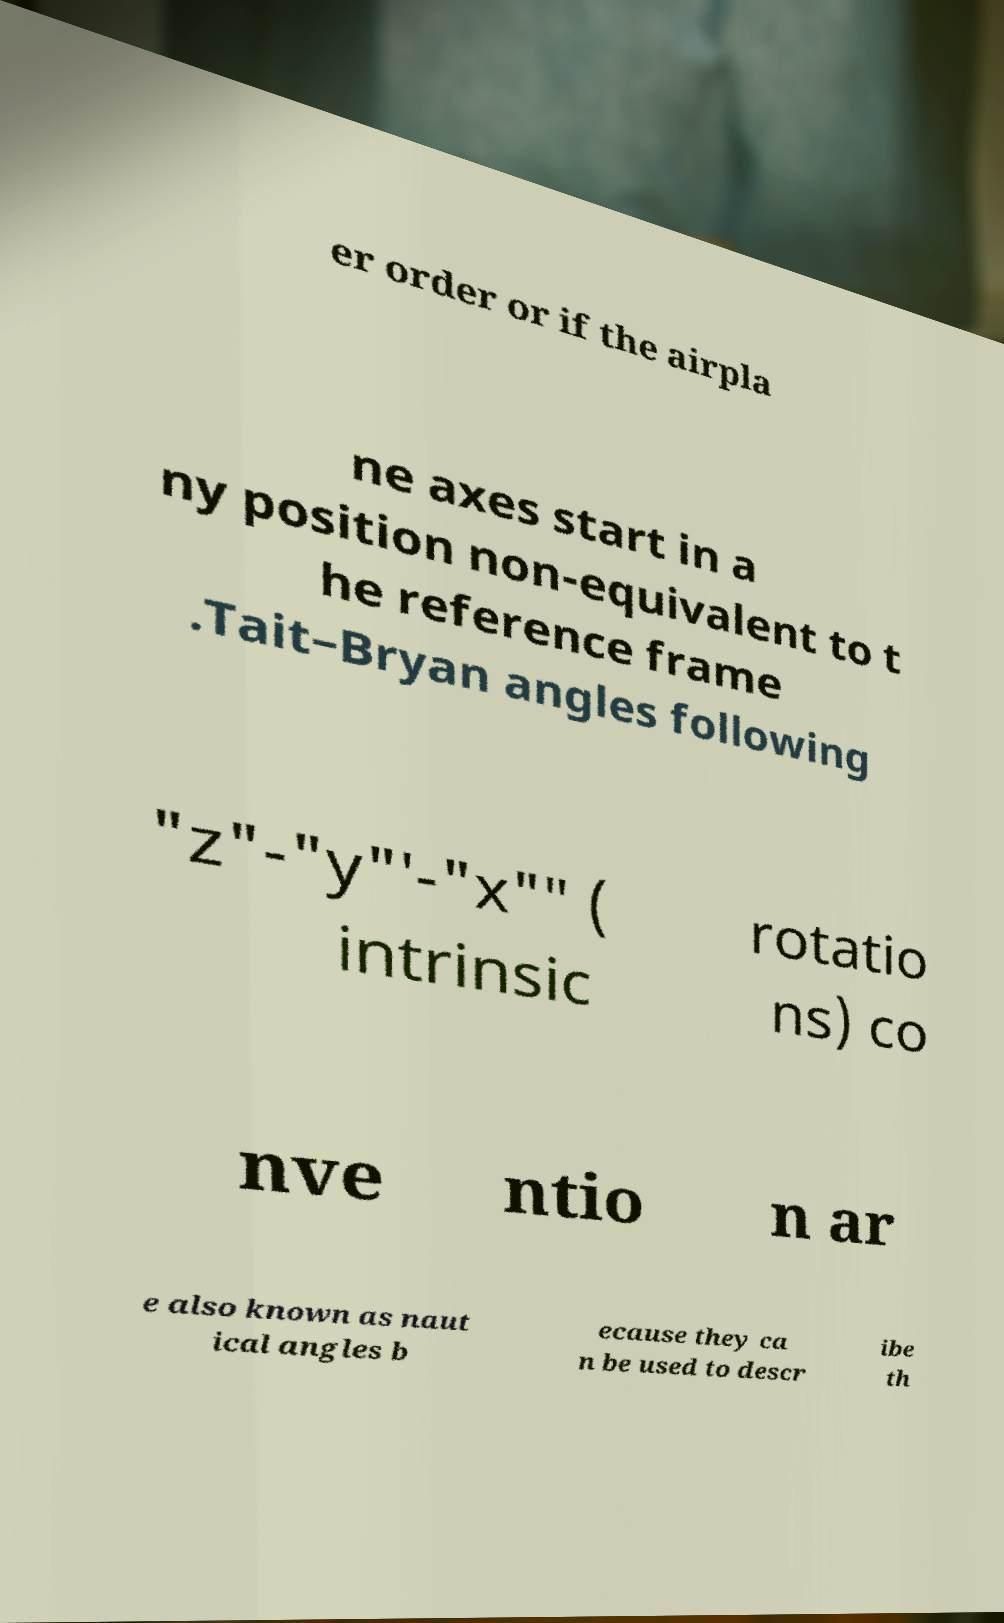What messages or text are displayed in this image? I need them in a readable, typed format. er order or if the airpla ne axes start in a ny position non-equivalent to t he reference frame .Tait–Bryan angles following "z"-"y"′-"x"″ ( intrinsic rotatio ns) co nve ntio n ar e also known as naut ical angles b ecause they ca n be used to descr ibe th 